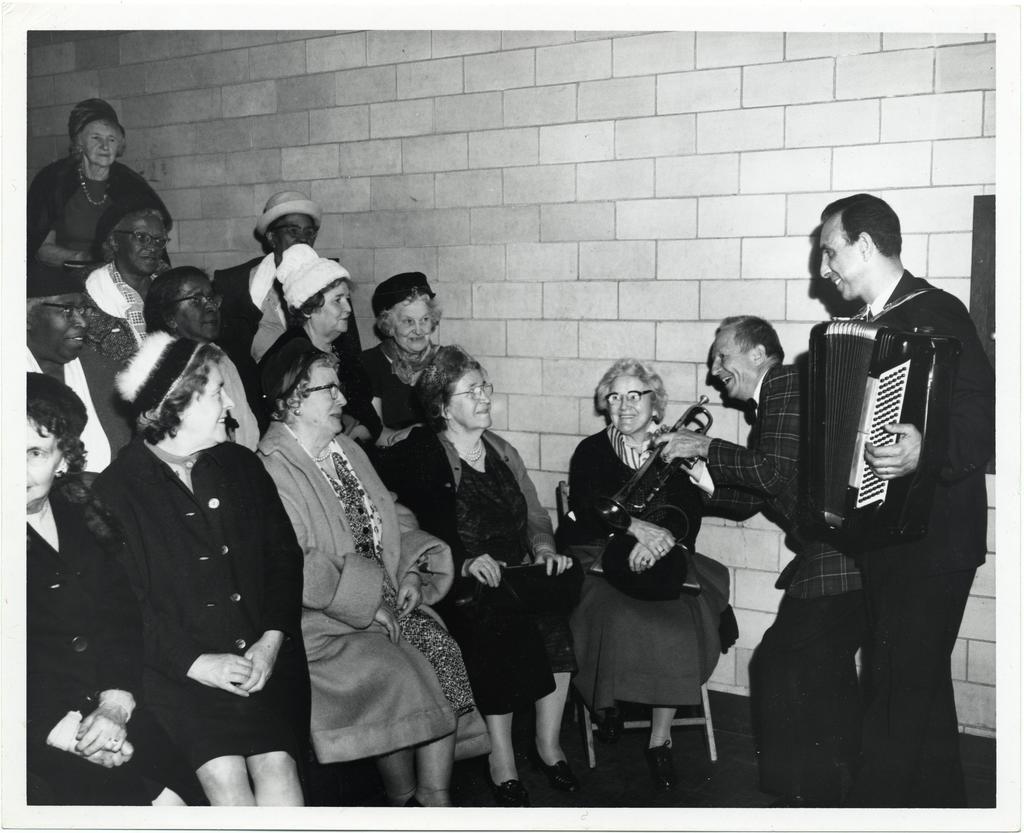Could you give a brief overview of what you see in this image? In this image we can see black and white picture of a group of persons, some women are sitting on chairs and some are standing. On the right side of the image we can see a person holding a musical instrument in his hands. One person is holding a trumpet with his hands. In the background, we can see the wall. 